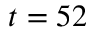<formula> <loc_0><loc_0><loc_500><loc_500>t = 5 2</formula> 